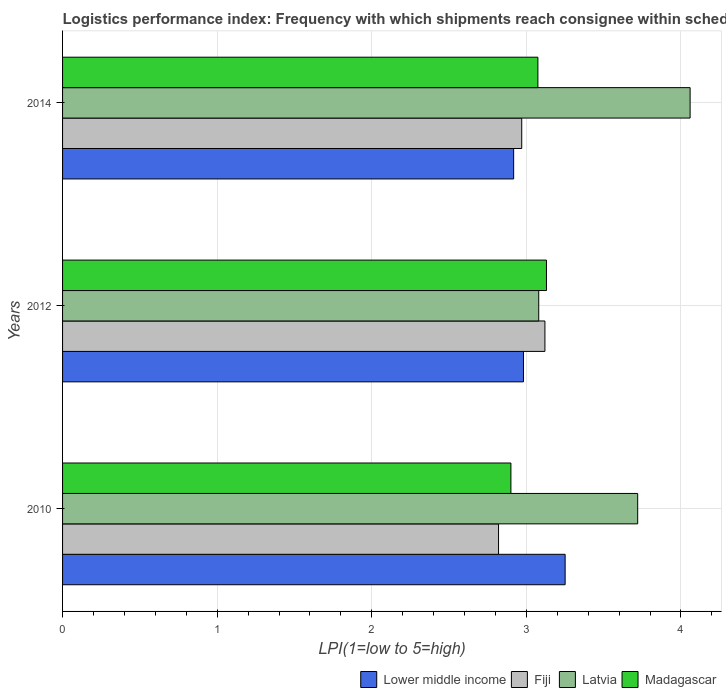Are the number of bars per tick equal to the number of legend labels?
Ensure brevity in your answer.  Yes. Are the number of bars on each tick of the Y-axis equal?
Your response must be concise. Yes. How many bars are there on the 1st tick from the top?
Your answer should be compact. 4. How many bars are there on the 3rd tick from the bottom?
Provide a short and direct response. 4. What is the label of the 2nd group of bars from the top?
Provide a succinct answer. 2012. In how many cases, is the number of bars for a given year not equal to the number of legend labels?
Ensure brevity in your answer.  0. What is the logistics performance index in Latvia in 2010?
Keep it short and to the point. 3.72. Across all years, what is the maximum logistics performance index in Lower middle income?
Ensure brevity in your answer.  3.25. Across all years, what is the minimum logistics performance index in Latvia?
Your answer should be compact. 3.08. In which year was the logistics performance index in Latvia minimum?
Ensure brevity in your answer.  2012. What is the total logistics performance index in Madagascar in the graph?
Give a very brief answer. 9.1. What is the difference between the logistics performance index in Lower middle income in 2012 and that in 2014?
Keep it short and to the point. 0.06. What is the difference between the logistics performance index in Latvia in 2010 and the logistics performance index in Fiji in 2012?
Provide a short and direct response. 0.6. What is the average logistics performance index in Lower middle income per year?
Your answer should be very brief. 3.05. In the year 2012, what is the difference between the logistics performance index in Latvia and logistics performance index in Lower middle income?
Keep it short and to the point. 0.1. In how many years, is the logistics performance index in Latvia greater than 3.2 ?
Provide a short and direct response. 2. What is the ratio of the logistics performance index in Madagascar in 2010 to that in 2014?
Your answer should be compact. 0.94. What is the difference between the highest and the second highest logistics performance index in Fiji?
Offer a terse response. 0.15. What is the difference between the highest and the lowest logistics performance index in Madagascar?
Ensure brevity in your answer.  0.23. In how many years, is the logistics performance index in Latvia greater than the average logistics performance index in Latvia taken over all years?
Give a very brief answer. 2. What does the 1st bar from the top in 2014 represents?
Offer a terse response. Madagascar. What does the 2nd bar from the bottom in 2010 represents?
Provide a short and direct response. Fiji. Is it the case that in every year, the sum of the logistics performance index in Lower middle income and logistics performance index in Fiji is greater than the logistics performance index in Madagascar?
Your answer should be compact. Yes. How many bars are there?
Give a very brief answer. 12. How many years are there in the graph?
Keep it short and to the point. 3. What is the difference between two consecutive major ticks on the X-axis?
Offer a terse response. 1. Does the graph contain grids?
Provide a succinct answer. Yes. How are the legend labels stacked?
Your answer should be compact. Horizontal. What is the title of the graph?
Your response must be concise. Logistics performance index: Frequency with which shipments reach consignee within scheduled time. Does "Malawi" appear as one of the legend labels in the graph?
Give a very brief answer. No. What is the label or title of the X-axis?
Provide a short and direct response. LPI(1=low to 5=high). What is the LPI(1=low to 5=high) in Lower middle income in 2010?
Your answer should be very brief. 3.25. What is the LPI(1=low to 5=high) of Fiji in 2010?
Your response must be concise. 2.82. What is the LPI(1=low to 5=high) in Latvia in 2010?
Provide a short and direct response. 3.72. What is the LPI(1=low to 5=high) in Madagascar in 2010?
Your answer should be compact. 2.9. What is the LPI(1=low to 5=high) in Lower middle income in 2012?
Ensure brevity in your answer.  2.98. What is the LPI(1=low to 5=high) in Fiji in 2012?
Ensure brevity in your answer.  3.12. What is the LPI(1=low to 5=high) of Latvia in 2012?
Your answer should be compact. 3.08. What is the LPI(1=low to 5=high) in Madagascar in 2012?
Offer a terse response. 3.13. What is the LPI(1=low to 5=high) of Lower middle income in 2014?
Ensure brevity in your answer.  2.92. What is the LPI(1=low to 5=high) in Fiji in 2014?
Your answer should be compact. 2.97. What is the LPI(1=low to 5=high) in Latvia in 2014?
Give a very brief answer. 4.06. What is the LPI(1=low to 5=high) in Madagascar in 2014?
Keep it short and to the point. 3.07. Across all years, what is the maximum LPI(1=low to 5=high) of Lower middle income?
Your answer should be very brief. 3.25. Across all years, what is the maximum LPI(1=low to 5=high) of Fiji?
Offer a terse response. 3.12. Across all years, what is the maximum LPI(1=low to 5=high) of Latvia?
Ensure brevity in your answer.  4.06. Across all years, what is the maximum LPI(1=low to 5=high) in Madagascar?
Your answer should be compact. 3.13. Across all years, what is the minimum LPI(1=low to 5=high) of Lower middle income?
Your response must be concise. 2.92. Across all years, what is the minimum LPI(1=low to 5=high) of Fiji?
Your response must be concise. 2.82. Across all years, what is the minimum LPI(1=low to 5=high) in Latvia?
Your answer should be compact. 3.08. What is the total LPI(1=low to 5=high) of Lower middle income in the graph?
Offer a terse response. 9.15. What is the total LPI(1=low to 5=high) in Fiji in the graph?
Offer a terse response. 8.91. What is the total LPI(1=low to 5=high) of Latvia in the graph?
Keep it short and to the point. 10.86. What is the total LPI(1=low to 5=high) of Madagascar in the graph?
Offer a terse response. 9.1. What is the difference between the LPI(1=low to 5=high) in Lower middle income in 2010 and that in 2012?
Keep it short and to the point. 0.27. What is the difference between the LPI(1=low to 5=high) in Fiji in 2010 and that in 2012?
Ensure brevity in your answer.  -0.3. What is the difference between the LPI(1=low to 5=high) in Latvia in 2010 and that in 2012?
Your answer should be very brief. 0.64. What is the difference between the LPI(1=low to 5=high) of Madagascar in 2010 and that in 2012?
Ensure brevity in your answer.  -0.23. What is the difference between the LPI(1=low to 5=high) in Lower middle income in 2010 and that in 2014?
Provide a short and direct response. 0.33. What is the difference between the LPI(1=low to 5=high) in Fiji in 2010 and that in 2014?
Give a very brief answer. -0.15. What is the difference between the LPI(1=low to 5=high) in Latvia in 2010 and that in 2014?
Your answer should be very brief. -0.34. What is the difference between the LPI(1=low to 5=high) of Madagascar in 2010 and that in 2014?
Give a very brief answer. -0.17. What is the difference between the LPI(1=low to 5=high) of Lower middle income in 2012 and that in 2014?
Offer a very short reply. 0.06. What is the difference between the LPI(1=low to 5=high) in Fiji in 2012 and that in 2014?
Your answer should be very brief. 0.15. What is the difference between the LPI(1=low to 5=high) in Latvia in 2012 and that in 2014?
Your response must be concise. -0.98. What is the difference between the LPI(1=low to 5=high) of Madagascar in 2012 and that in 2014?
Provide a succinct answer. 0.06. What is the difference between the LPI(1=low to 5=high) of Lower middle income in 2010 and the LPI(1=low to 5=high) of Fiji in 2012?
Offer a very short reply. 0.13. What is the difference between the LPI(1=low to 5=high) in Lower middle income in 2010 and the LPI(1=low to 5=high) in Latvia in 2012?
Give a very brief answer. 0.17. What is the difference between the LPI(1=low to 5=high) in Lower middle income in 2010 and the LPI(1=low to 5=high) in Madagascar in 2012?
Give a very brief answer. 0.12. What is the difference between the LPI(1=low to 5=high) of Fiji in 2010 and the LPI(1=low to 5=high) of Latvia in 2012?
Ensure brevity in your answer.  -0.26. What is the difference between the LPI(1=low to 5=high) in Fiji in 2010 and the LPI(1=low to 5=high) in Madagascar in 2012?
Provide a succinct answer. -0.31. What is the difference between the LPI(1=low to 5=high) of Latvia in 2010 and the LPI(1=low to 5=high) of Madagascar in 2012?
Ensure brevity in your answer.  0.59. What is the difference between the LPI(1=low to 5=high) of Lower middle income in 2010 and the LPI(1=low to 5=high) of Fiji in 2014?
Make the answer very short. 0.28. What is the difference between the LPI(1=low to 5=high) in Lower middle income in 2010 and the LPI(1=low to 5=high) in Latvia in 2014?
Provide a short and direct response. -0.81. What is the difference between the LPI(1=low to 5=high) of Lower middle income in 2010 and the LPI(1=low to 5=high) of Madagascar in 2014?
Offer a terse response. 0.18. What is the difference between the LPI(1=low to 5=high) of Fiji in 2010 and the LPI(1=low to 5=high) of Latvia in 2014?
Ensure brevity in your answer.  -1.24. What is the difference between the LPI(1=low to 5=high) of Fiji in 2010 and the LPI(1=low to 5=high) of Madagascar in 2014?
Offer a terse response. -0.25. What is the difference between the LPI(1=low to 5=high) in Latvia in 2010 and the LPI(1=low to 5=high) in Madagascar in 2014?
Keep it short and to the point. 0.65. What is the difference between the LPI(1=low to 5=high) in Lower middle income in 2012 and the LPI(1=low to 5=high) in Fiji in 2014?
Keep it short and to the point. 0.01. What is the difference between the LPI(1=low to 5=high) of Lower middle income in 2012 and the LPI(1=low to 5=high) of Latvia in 2014?
Your answer should be compact. -1.08. What is the difference between the LPI(1=low to 5=high) in Lower middle income in 2012 and the LPI(1=low to 5=high) in Madagascar in 2014?
Provide a short and direct response. -0.09. What is the difference between the LPI(1=low to 5=high) of Fiji in 2012 and the LPI(1=low to 5=high) of Latvia in 2014?
Your answer should be compact. -0.94. What is the difference between the LPI(1=low to 5=high) of Fiji in 2012 and the LPI(1=low to 5=high) of Madagascar in 2014?
Keep it short and to the point. 0.05. What is the difference between the LPI(1=low to 5=high) in Latvia in 2012 and the LPI(1=low to 5=high) in Madagascar in 2014?
Provide a short and direct response. 0.01. What is the average LPI(1=low to 5=high) of Lower middle income per year?
Offer a very short reply. 3.05. What is the average LPI(1=low to 5=high) of Fiji per year?
Provide a short and direct response. 2.97. What is the average LPI(1=low to 5=high) in Latvia per year?
Your answer should be compact. 3.62. What is the average LPI(1=low to 5=high) in Madagascar per year?
Offer a terse response. 3.03. In the year 2010, what is the difference between the LPI(1=low to 5=high) of Lower middle income and LPI(1=low to 5=high) of Fiji?
Offer a very short reply. 0.43. In the year 2010, what is the difference between the LPI(1=low to 5=high) of Lower middle income and LPI(1=low to 5=high) of Latvia?
Provide a short and direct response. -0.47. In the year 2010, what is the difference between the LPI(1=low to 5=high) in Lower middle income and LPI(1=low to 5=high) in Madagascar?
Provide a short and direct response. 0.35. In the year 2010, what is the difference between the LPI(1=low to 5=high) in Fiji and LPI(1=low to 5=high) in Madagascar?
Offer a terse response. -0.08. In the year 2010, what is the difference between the LPI(1=low to 5=high) in Latvia and LPI(1=low to 5=high) in Madagascar?
Offer a terse response. 0.82. In the year 2012, what is the difference between the LPI(1=low to 5=high) in Lower middle income and LPI(1=low to 5=high) in Fiji?
Your answer should be very brief. -0.14. In the year 2012, what is the difference between the LPI(1=low to 5=high) of Lower middle income and LPI(1=low to 5=high) of Latvia?
Keep it short and to the point. -0.1. In the year 2012, what is the difference between the LPI(1=low to 5=high) of Lower middle income and LPI(1=low to 5=high) of Madagascar?
Your response must be concise. -0.15. In the year 2012, what is the difference between the LPI(1=low to 5=high) of Fiji and LPI(1=low to 5=high) of Latvia?
Keep it short and to the point. 0.04. In the year 2012, what is the difference between the LPI(1=low to 5=high) in Fiji and LPI(1=low to 5=high) in Madagascar?
Offer a terse response. -0.01. In the year 2012, what is the difference between the LPI(1=low to 5=high) in Latvia and LPI(1=low to 5=high) in Madagascar?
Your answer should be very brief. -0.05. In the year 2014, what is the difference between the LPI(1=low to 5=high) in Lower middle income and LPI(1=low to 5=high) in Fiji?
Your response must be concise. -0.05. In the year 2014, what is the difference between the LPI(1=low to 5=high) of Lower middle income and LPI(1=low to 5=high) of Latvia?
Offer a terse response. -1.14. In the year 2014, what is the difference between the LPI(1=low to 5=high) of Lower middle income and LPI(1=low to 5=high) of Madagascar?
Provide a succinct answer. -0.16. In the year 2014, what is the difference between the LPI(1=low to 5=high) of Fiji and LPI(1=low to 5=high) of Latvia?
Provide a succinct answer. -1.09. In the year 2014, what is the difference between the LPI(1=low to 5=high) in Fiji and LPI(1=low to 5=high) in Madagascar?
Provide a succinct answer. -0.1. In the year 2014, what is the difference between the LPI(1=low to 5=high) in Latvia and LPI(1=low to 5=high) in Madagascar?
Your answer should be compact. 0.98. What is the ratio of the LPI(1=low to 5=high) of Lower middle income in 2010 to that in 2012?
Your answer should be very brief. 1.09. What is the ratio of the LPI(1=low to 5=high) in Fiji in 2010 to that in 2012?
Make the answer very short. 0.9. What is the ratio of the LPI(1=low to 5=high) of Latvia in 2010 to that in 2012?
Give a very brief answer. 1.21. What is the ratio of the LPI(1=low to 5=high) in Madagascar in 2010 to that in 2012?
Offer a very short reply. 0.93. What is the ratio of the LPI(1=low to 5=high) in Lower middle income in 2010 to that in 2014?
Ensure brevity in your answer.  1.11. What is the ratio of the LPI(1=low to 5=high) in Fiji in 2010 to that in 2014?
Your response must be concise. 0.95. What is the ratio of the LPI(1=low to 5=high) of Latvia in 2010 to that in 2014?
Your answer should be compact. 0.92. What is the ratio of the LPI(1=low to 5=high) in Madagascar in 2010 to that in 2014?
Your answer should be compact. 0.94. What is the ratio of the LPI(1=low to 5=high) of Lower middle income in 2012 to that in 2014?
Make the answer very short. 1.02. What is the ratio of the LPI(1=low to 5=high) of Fiji in 2012 to that in 2014?
Your response must be concise. 1.05. What is the ratio of the LPI(1=low to 5=high) of Latvia in 2012 to that in 2014?
Keep it short and to the point. 0.76. What is the ratio of the LPI(1=low to 5=high) in Madagascar in 2012 to that in 2014?
Offer a very short reply. 1.02. What is the difference between the highest and the second highest LPI(1=low to 5=high) in Lower middle income?
Your response must be concise. 0.27. What is the difference between the highest and the second highest LPI(1=low to 5=high) of Latvia?
Your answer should be compact. 0.34. What is the difference between the highest and the second highest LPI(1=low to 5=high) in Madagascar?
Give a very brief answer. 0.06. What is the difference between the highest and the lowest LPI(1=low to 5=high) in Lower middle income?
Provide a short and direct response. 0.33. What is the difference between the highest and the lowest LPI(1=low to 5=high) in Latvia?
Give a very brief answer. 0.98. What is the difference between the highest and the lowest LPI(1=low to 5=high) of Madagascar?
Your answer should be compact. 0.23. 